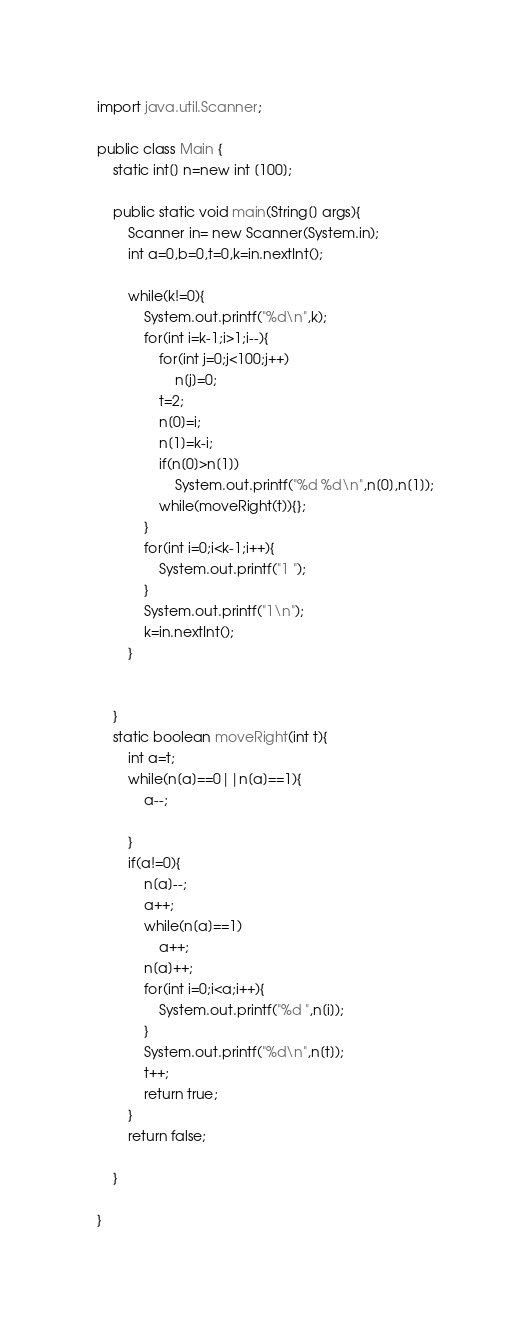Convert code to text. <code><loc_0><loc_0><loc_500><loc_500><_Java_>import java.util.Scanner;

public class Main {
	static int[] n=new int [100];
	
	public static void main(String[] args){
		Scanner in= new Scanner(System.in);
		int a=0,b=0,t=0,k=in.nextInt();
		
		while(k!=0){
			System.out.printf("%d\n",k);
			for(int i=k-1;i>1;i--){
				for(int j=0;j<100;j++)
					n[j]=0;
				t=2;
				n[0]=i;
				n[1]=k-i;
				if(n[0]>n[1])
					System.out.printf("%d %d\n",n[0],n[1]);
				while(moveRight(t)){};
			}
			for(int i=0;i<k-1;i++){
				System.out.printf("1 ");
			}
			System.out.printf("1\n");
			k=in.nextInt();
		}
		
		
	}
	static boolean moveRight(int t){
		int a=t;
		while(n[a]==0||n[a]==1){
			a--;
			
		}
		if(a!=0){
			n[a]--;
			a++;
			while(n[a]==1)
				a++;
			n[a]++;
			for(int i=0;i<a;i++){
				System.out.printf("%d ",n[i]);
			}
			System.out.printf("%d\n",n[t]);
			t++;
			return true;
		}
		return false;
		
	}
	
}</code> 